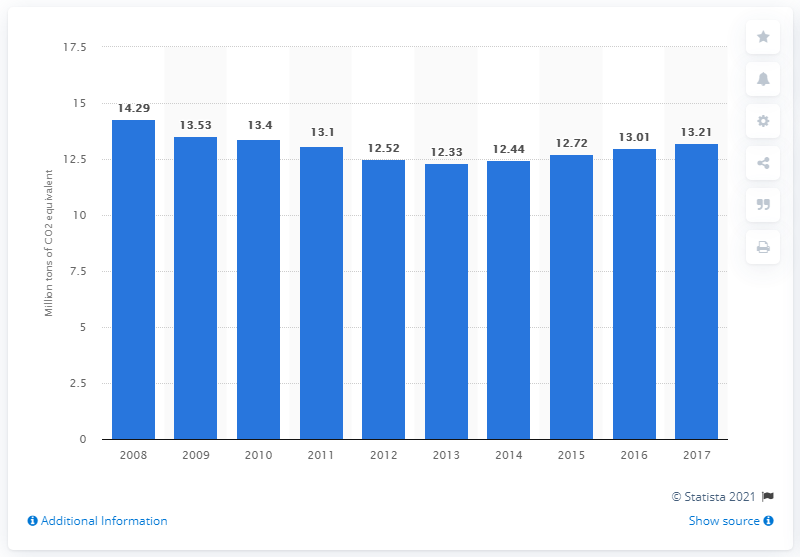Indicate a few pertinent items in this graphic. In 2017, fuel combustion in Denmark emitted a total of 13.21 units of CO2 equivalent. 